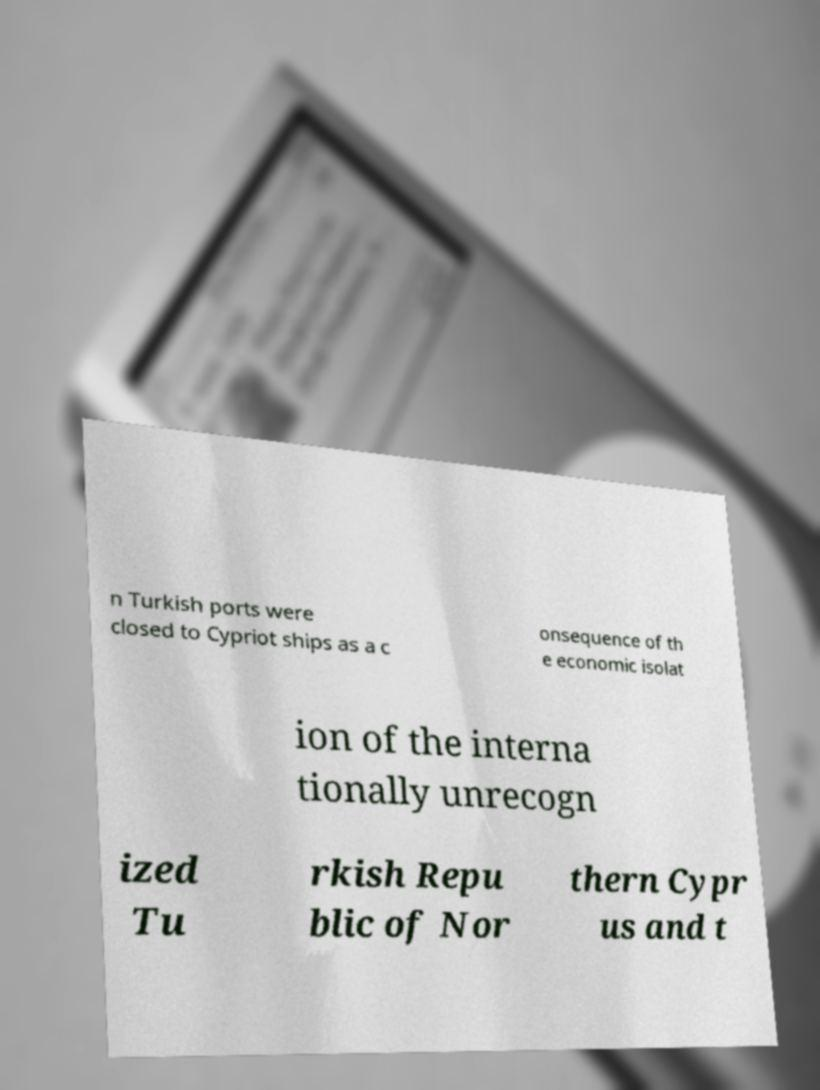Can you accurately transcribe the text from the provided image for me? n Turkish ports were closed to Cypriot ships as a c onsequence of th e economic isolat ion of the interna tionally unrecogn ized Tu rkish Repu blic of Nor thern Cypr us and t 